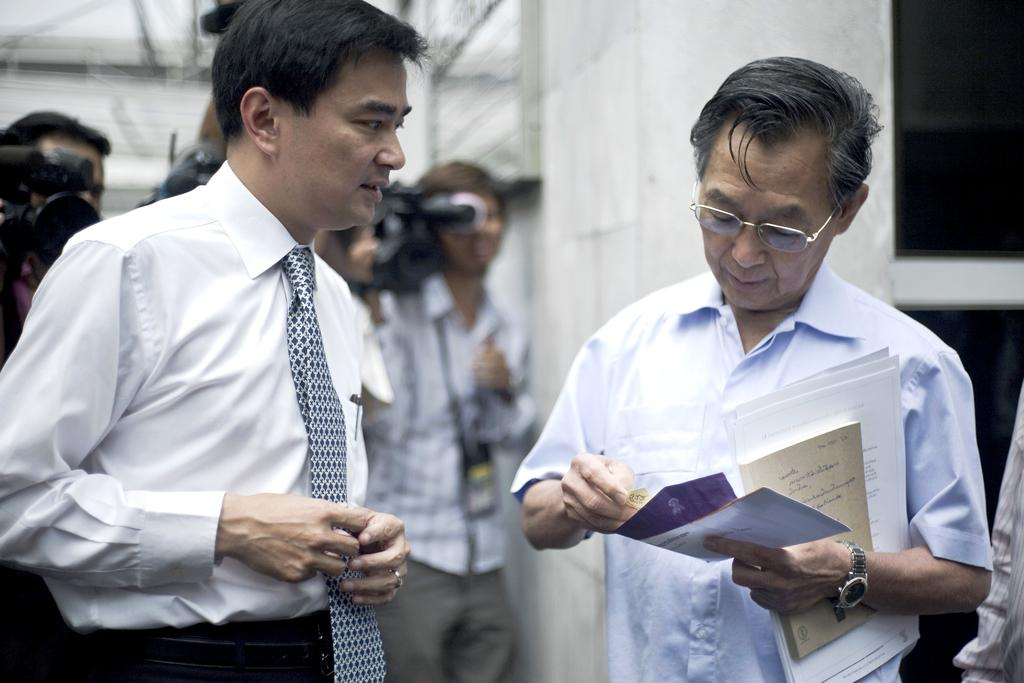What is happening in the image? There are people standing in the image. Can you describe what one of the individuals is holding? A man on the right side is holding papers. What can be seen in the background of the image? There is a camera and a wall visible in the background of the image. What is the price of the polish being sold by the doctor in the image? There is no doctor or polish present in the image, so it is not possible to determine the price of any polish. 